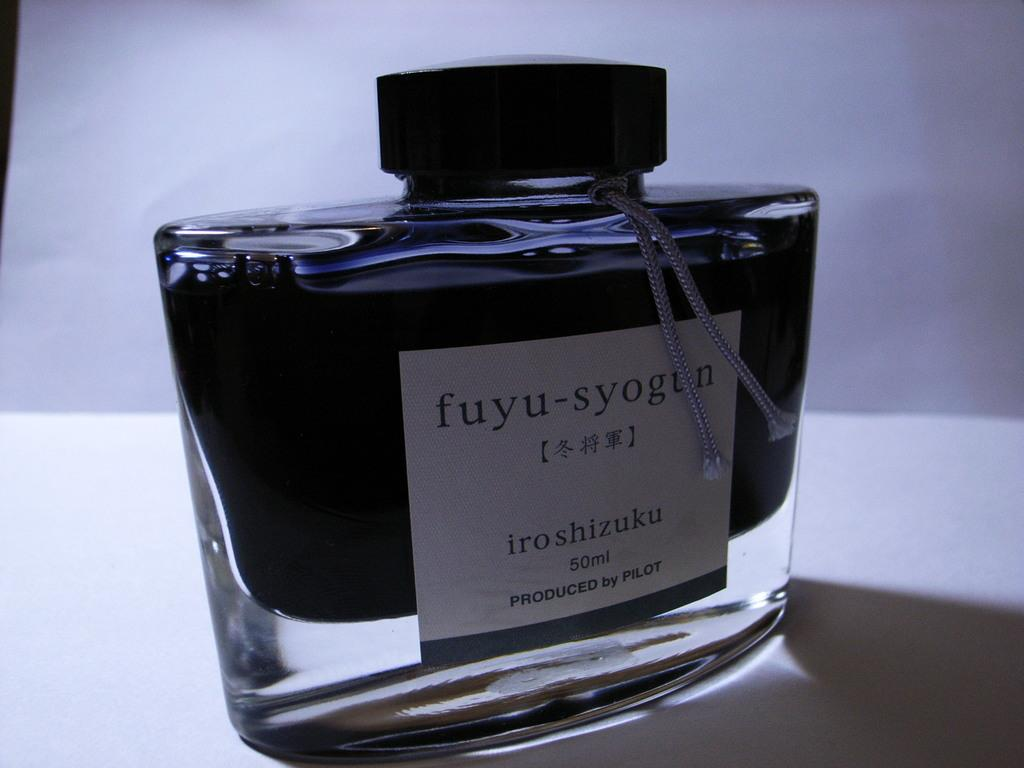Provide a one-sentence caption for the provided image. A 50ml bottle of fuyu-syogun cologne produced by Pilot. 